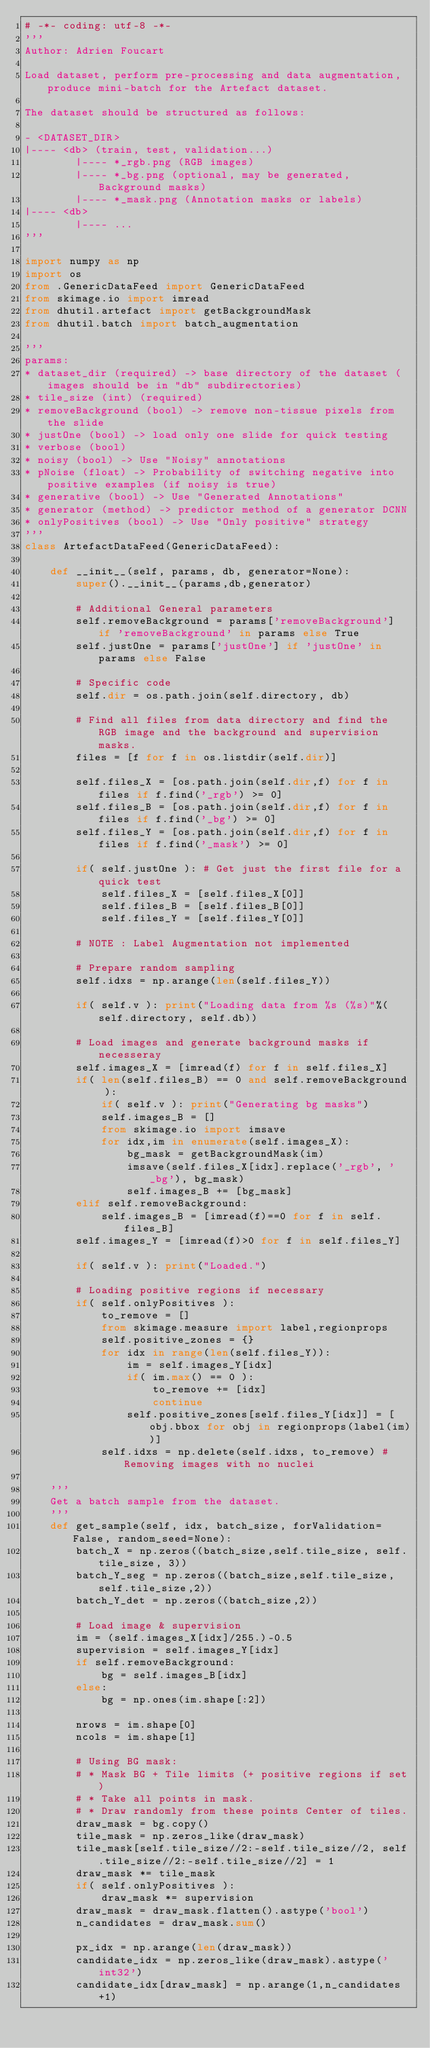<code> <loc_0><loc_0><loc_500><loc_500><_Python_># -*- coding: utf-8 -*-
'''
Author: Adrien Foucart

Load dataset, perform pre-processing and data augmentation, produce mini-batch for the Artefact dataset.

The dataset should be structured as follows:

- <DATASET_DIR>
|---- <db> (train, test, validation...)
        |---- *_rgb.png (RGB images)
        |---- *_bg.png (optional, may be generated, Background masks)
        |---- *_mask.png (Annotation masks or labels)
|---- <db>
        |---- ...
'''

import numpy as np
import os
from .GenericDataFeed import GenericDataFeed
from skimage.io import imread
from dhutil.artefact import getBackgroundMask 
from dhutil.batch import batch_augmentation

'''
params:
* dataset_dir (required) -> base directory of the dataset (images should be in "db" subdirectories)
* tile_size (int) (required)
* removeBackground (bool) -> remove non-tissue pixels from the slide
* justOne (bool) -> load only one slide for quick testing
* verbose (bool)
* noisy (bool) -> Use "Noisy" annotations
* pNoise (float) -> Probability of switching negative into positive examples (if noisy is true)
* generative (bool) -> Use "Generated Annotations"
* generator (method) -> predictor method of a generator DCNN
* onlyPositives (bool) -> Use "Only positive" strategy 
'''
class ArtefactDataFeed(GenericDataFeed):

    def __init__(self, params, db, generator=None):
        super().__init__(params,db,generator)

        # Additional General parameters
        self.removeBackground = params['removeBackground'] if 'removeBackground' in params else True
        self.justOne = params['justOne'] if 'justOne' in params else False
        
        # Specific code
        self.dir = os.path.join(self.directory, db)
        
        # Find all files from data directory and find the RGB image and the background and supervision masks.
        files = [f for f in os.listdir(self.dir)]
        
        self.files_X = [os.path.join(self.dir,f) for f in files if f.find('_rgb') >= 0]
        self.files_B = [os.path.join(self.dir,f) for f in files if f.find('_bg') >= 0]
        self.files_Y = [os.path.join(self.dir,f) for f in files if f.find('_mask') >= 0]

        if( self.justOne ): # Get just the first file for a quick test
            self.files_X = [self.files_X[0]]
            self.files_B = [self.files_B[0]]
            self.files_Y = [self.files_Y[0]]

        # NOTE : Label Augmentation not implemented

        # Prepare random sampling
        self.idxs = np.arange(len(self.files_Y))

        if( self.v ): print("Loading data from %s (%s)"%(self.directory, self.db))

        # Load images and generate background masks if necesseray
        self.images_X = [imread(f) for f in self.files_X]
        if( len(self.files_B) == 0 and self.removeBackground ):
            if( self.v ): print("Generating bg masks")
            self.images_B = []
            from skimage.io import imsave
            for idx,im in enumerate(self.images_X):
                bg_mask = getBackgroundMask(im)
                imsave(self.files_X[idx].replace('_rgb', '_bg'), bg_mask)
                self.images_B += [bg_mask]
        elif self.removeBackground:
            self.images_B = [imread(f)==0 for f in self.files_B]
        self.images_Y = [imread(f)>0 for f in self.files_Y]

        if( self.v ): print("Loaded.")

        # Loading positive regions if necessary
        if( self.onlyPositives ):
            to_remove = []
            from skimage.measure import label,regionprops
            self.positive_zones = {}
            for idx in range(len(self.files_Y)):
                im = self.images_Y[idx]
                if( im.max() == 0 ): 
                    to_remove += [idx]
                    continue
                self.positive_zones[self.files_Y[idx]] = [obj.bbox for obj in regionprops(label(im))]
            self.idxs = np.delete(self.idxs, to_remove)	# Removing images with no nuclei

    '''
    Get a batch sample from the dataset.
    '''
    def get_sample(self, idx, batch_size, forValidation=False, random_seed=None):
        batch_X = np.zeros((batch_size,self.tile_size, self.tile_size, 3))
        batch_Y_seg = np.zeros((batch_size,self.tile_size,self.tile_size,2))
        batch_Y_det = np.zeros((batch_size,2))

        # Load image & supervision
        im = (self.images_X[idx]/255.)-0.5
        supervision = self.images_Y[idx]
        if self.removeBackground:
            bg = self.images_B[idx]
        else:
            bg = np.ones(im.shape[:2])

        nrows = im.shape[0]
        ncols = im.shape[1]

        # Using BG mask:
        # * Mask BG + Tile limits (+ positive regions if set)
        # * Take all points in mask.
        # * Draw randomly from these points Center of tiles.
        draw_mask = bg.copy()
        tile_mask = np.zeros_like(draw_mask)
        tile_mask[self.tile_size//2:-self.tile_size//2, self.tile_size//2:-self.tile_size//2] = 1
        draw_mask *= tile_mask
        if( self.onlyPositives ):
            draw_mask *= supervision
        draw_mask = draw_mask.flatten().astype('bool')
        n_candidates = draw_mask.sum()
        
        px_idx = np.arange(len(draw_mask))
        candidate_idx = np.zeros_like(draw_mask).astype('int32')
        candidate_idx[draw_mask] = np.arange(1,n_candidates+1)
</code> 